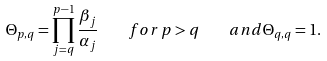<formula> <loc_0><loc_0><loc_500><loc_500>\Theta _ { p , q } = \prod _ { j = q } ^ { p - 1 } \frac { \beta _ { j } } { \alpha _ { j } } \quad f o r \, p > q \quad a n d \Theta _ { q , q } = 1 .</formula> 